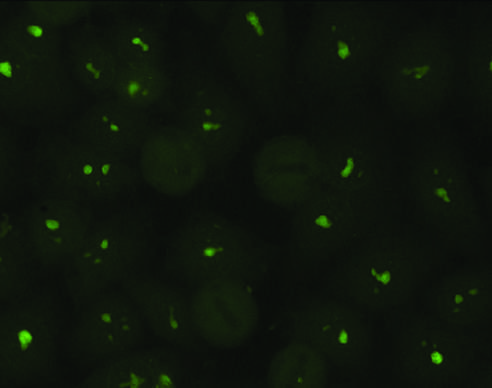how is a nucleolar pattern against nucleolar proteins?
Answer the question using a single word or phrase. Typical of antibodies 